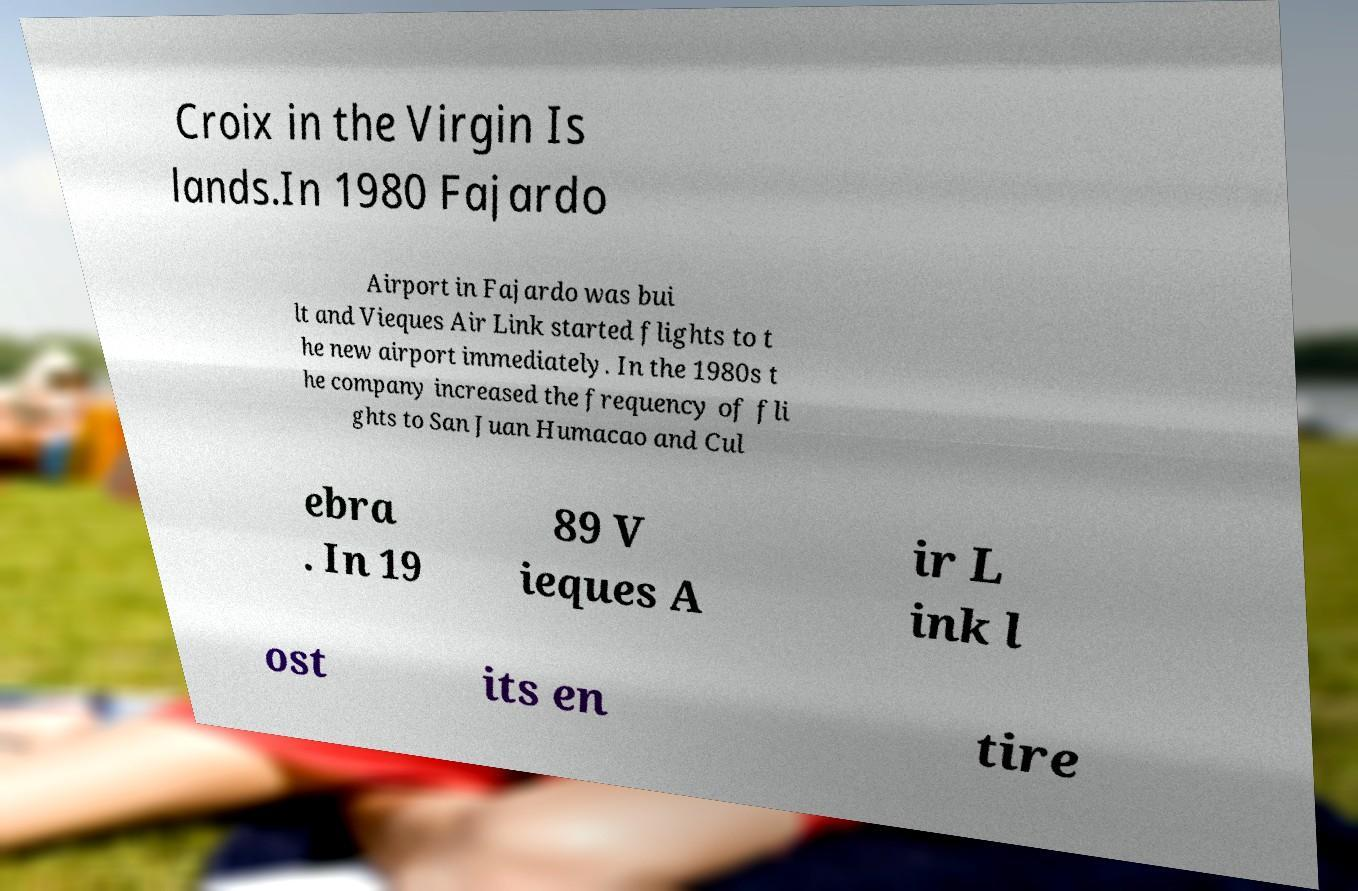For documentation purposes, I need the text within this image transcribed. Could you provide that? Croix in the Virgin Is lands.In 1980 Fajardo Airport in Fajardo was bui lt and Vieques Air Link started flights to t he new airport immediately. In the 1980s t he company increased the frequency of fli ghts to San Juan Humacao and Cul ebra . In 19 89 V ieques A ir L ink l ost its en tire 